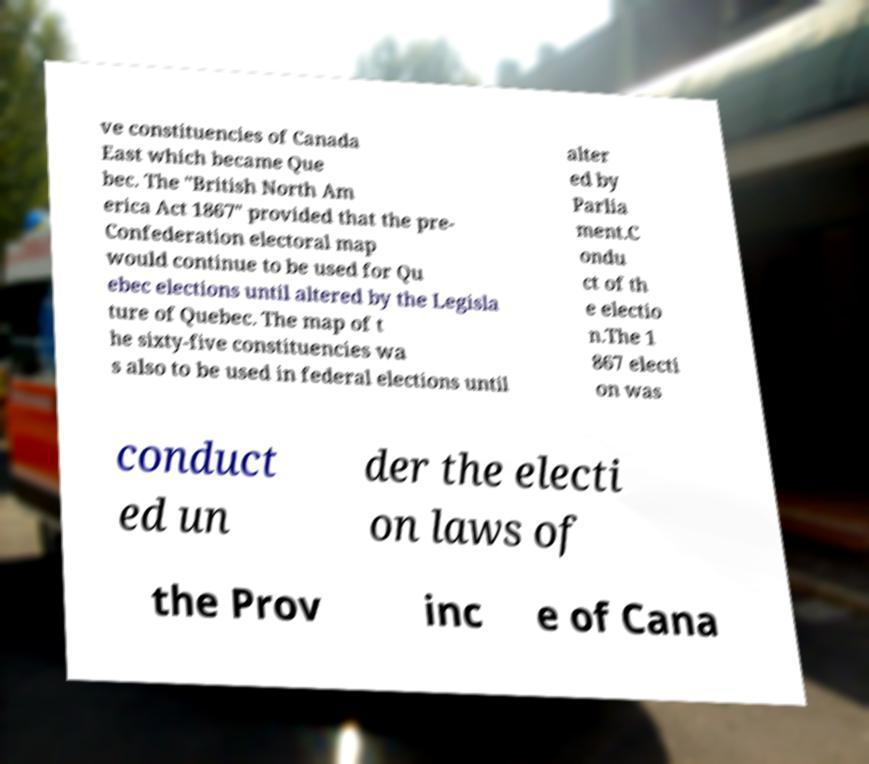I need the written content from this picture converted into text. Can you do that? ve constituencies of Canada East which became Que bec. The "British North Am erica Act 1867" provided that the pre- Confederation electoral map would continue to be used for Qu ebec elections until altered by the Legisla ture of Quebec. The map of t he sixty-five constituencies wa s also to be used in federal elections until alter ed by Parlia ment.C ondu ct of th e electio n.The 1 867 electi on was conduct ed un der the electi on laws of the Prov inc e of Cana 